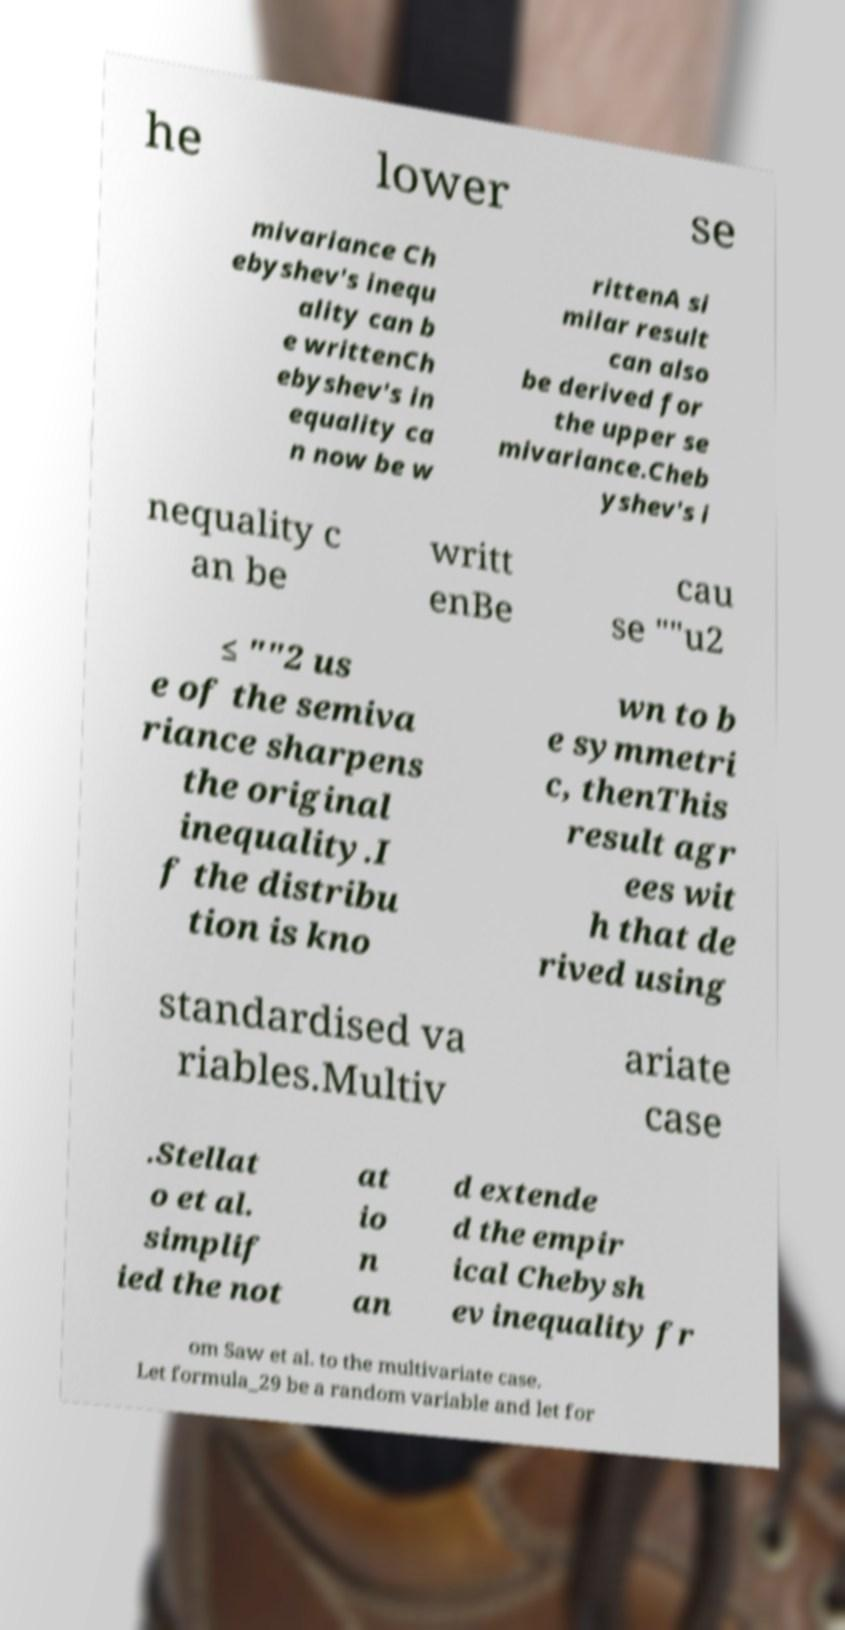For documentation purposes, I need the text within this image transcribed. Could you provide that? he lower se mivariance Ch ebyshev's inequ ality can b e writtenCh ebyshev's in equality ca n now be w rittenA si milar result can also be derived for the upper se mivariance.Cheb yshev's i nequality c an be writt enBe cau se ""u2 ≤ ""2 us e of the semiva riance sharpens the original inequality.I f the distribu tion is kno wn to b e symmetri c, thenThis result agr ees wit h that de rived using standardised va riables.Multiv ariate case .Stellat o et al. simplif ied the not at io n an d extende d the empir ical Chebysh ev inequality fr om Saw et al. to the multivariate case. Let formula_29 be a random variable and let for 